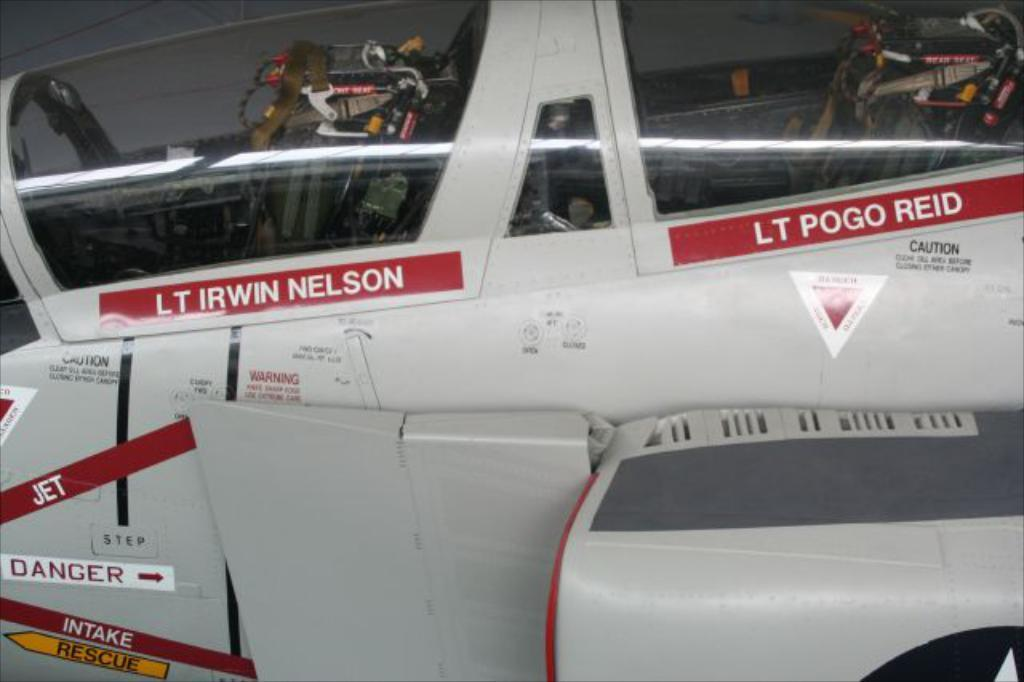<image>
Describe the image concisely. The names of lieutenants Irwin Nelson and Pogo Reid are attached to this vehicle 